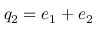<formula> <loc_0><loc_0><loc_500><loc_500>q _ { 2 } = e _ { 1 } + e _ { 2 }</formula> 